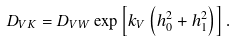Convert formula to latex. <formula><loc_0><loc_0><loc_500><loc_500>D _ { V K } = D _ { V W } \exp \left [ k _ { V } \left ( h _ { 0 } ^ { 2 } + h _ { 1 } ^ { 2 } \right ) \right ] .</formula> 